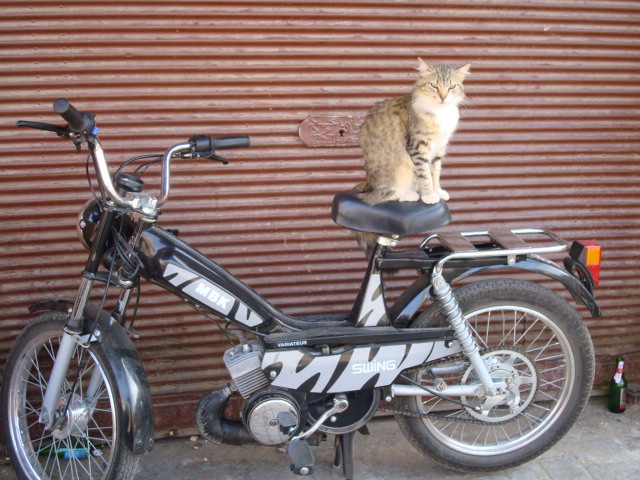Read all the text in this image. SWING 